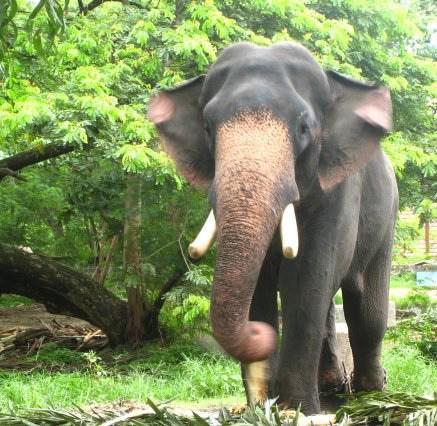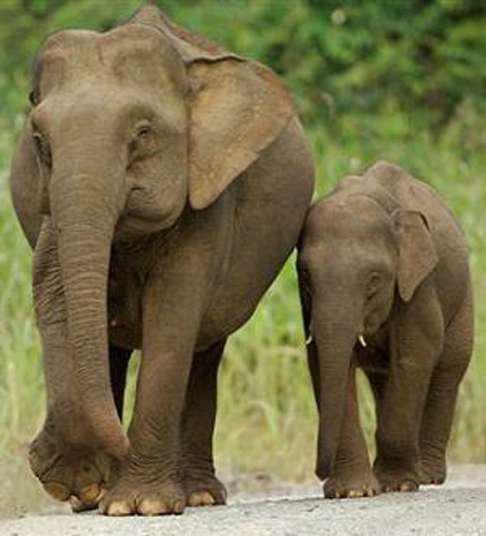The first image is the image on the left, the second image is the image on the right. Given the left and right images, does the statement "There are more animals in the image on the right." hold true? Answer yes or no. Yes. 